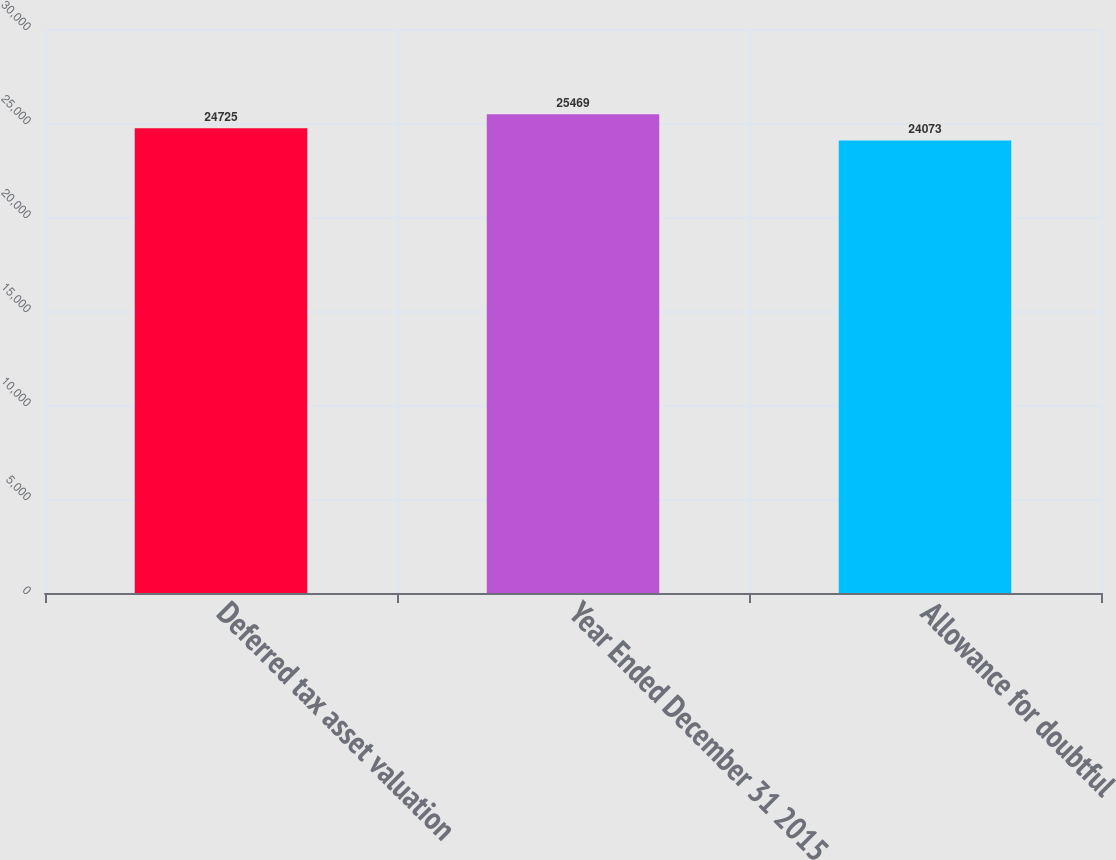<chart> <loc_0><loc_0><loc_500><loc_500><bar_chart><fcel>Deferred tax asset valuation<fcel>Year Ended December 31 2015<fcel>Allowance for doubtful<nl><fcel>24725<fcel>25469<fcel>24073<nl></chart> 